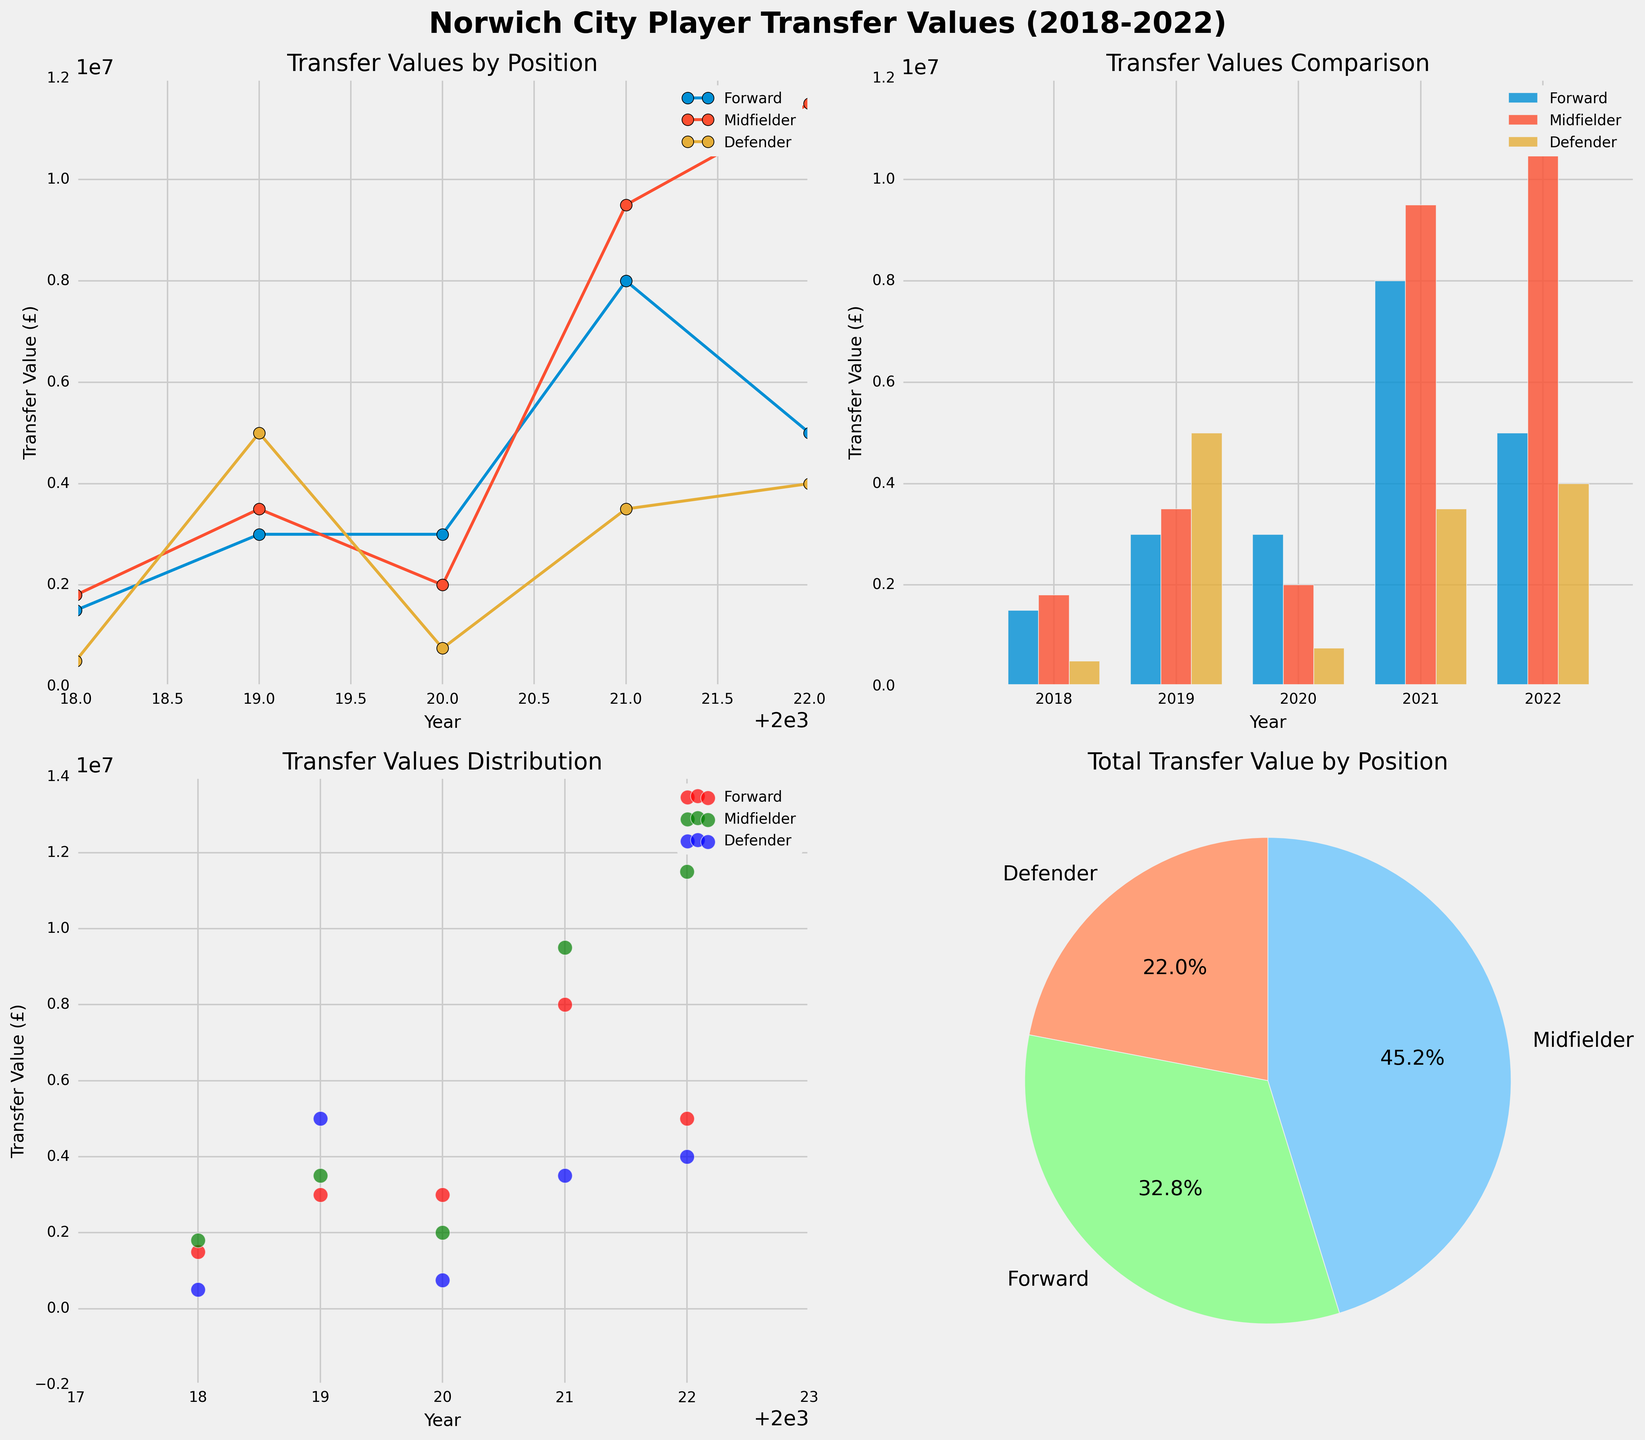What is the title of the entire figure? The title of the entire figure is displayed at the top, serving as an overall description of the visualizations. It reads "Norwich City Player Transfer Values (2018-2022)".
Answer: Norwich City Player Transfer Values (2018-2022) Which position has the highest total transfer value in the pie chart? To determine this, we look at the pie chart. Each slice represents a position's total transfer value proportion. The Midfielder position has the largest segment, indicating the highest total transfer value.
Answer: Midfielder How do the transfer values of forwards change over the years in the line plot? To answer this, trace the line labeled with "Forward" in the line plot. In 2018, it's £1,500,000; in 2019, £3,000,000; in 2020, £3,000,000; in 2021, £8,000,000; and in 2022, £5,000,000. Generally, it increases until 2021 and then drops slightly.
Answer: Increase until 2021, then decrease in 2022 Which year had the highest transfer value for defenders according to the bar plot? Look at the bar plot section for defenders for each year. The height of the bar for 2019 appears to be the highest, representing the maximum transfer value for defenders at £5,000,000.
Answer: 2019 What is the transfer value of Milot Rashica in 2021 as seen in the scatter plot? Find the scatter dot in 2021 that corresponds to a midfielder (green color). Milot Rashica's transfer value is marked at £9,500,000.
Answer: £9,500,000 Which position shows more variability in transfer values over the years in the scatter plot? To determine variability, observe the scatter plot and look at the spread of dots for each position. Midfielders (green dots) show a wide range from approximately £2,000,000 to £11,500,000, indicating more variability.
Answer: Midfielder What was the difference in transfer values between Josh Sargent and Adam Idah in 2022 according to the line plot? Josh Sargent's transfer value in 2022 was £8,000,000, while Adam Idah's was £5,000,000. The difference between their transfer values is calculated as £8,000,000 - £5,000,000 = £3,000,000.
Answer: £3,000,000 In the bar chart, which position had an equal transfer value in consecutive years? Check the bars for any positions' values that are equal in consecutive years. For 'Forward', the values in 2019 and 2020 both are £3,000,000.
Answer: Forward What is the average transfer value of defenders in the pie chart? From the pie chart, the proportion of total transfer values by position doesn't directly show numeric values. Use the data to calculate: (500000 + 5000000 + 750000 + 3500000 + 4000000) / 5 = £1,050,000.
Answer: £2,925,000 